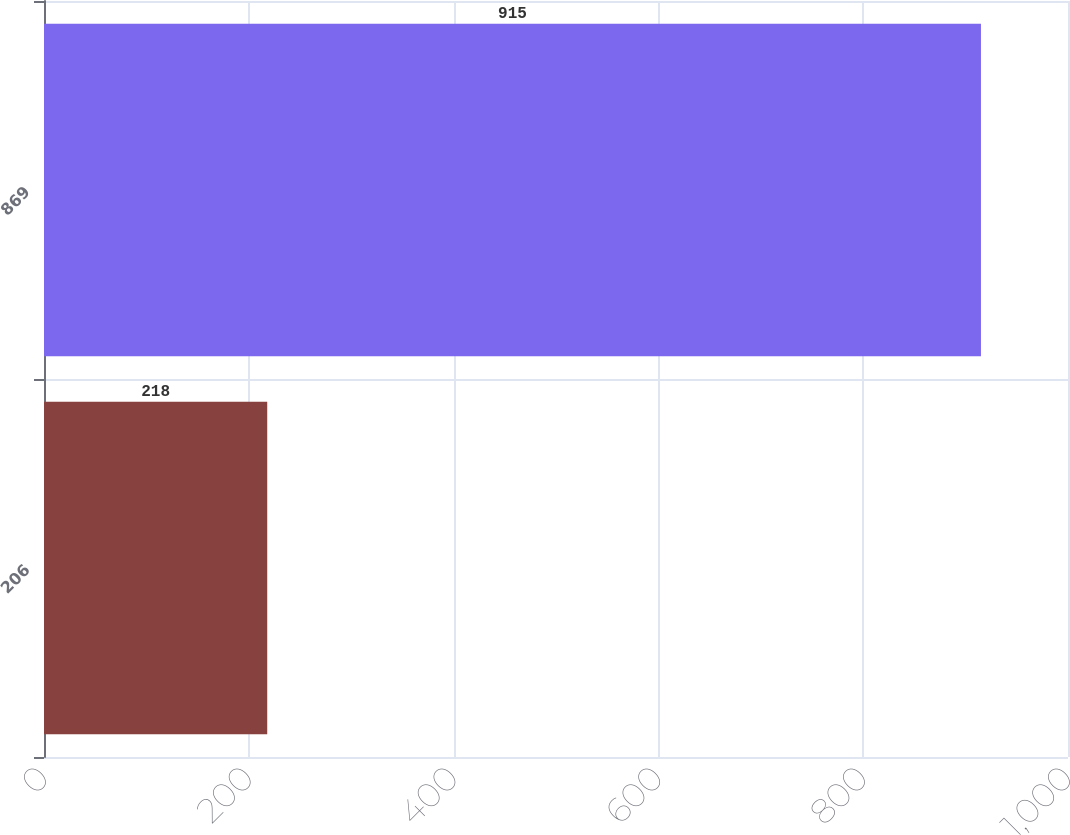Convert chart. <chart><loc_0><loc_0><loc_500><loc_500><bar_chart><fcel>206<fcel>869<nl><fcel>218<fcel>915<nl></chart> 